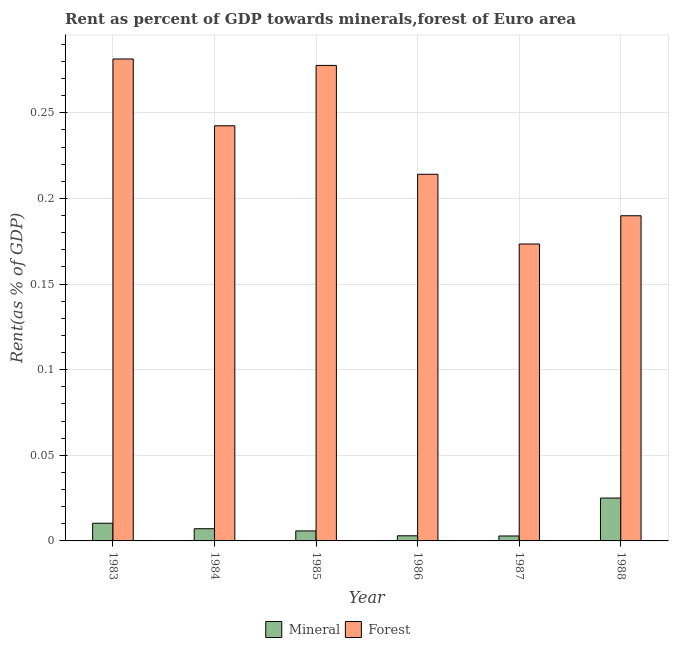How many different coloured bars are there?
Give a very brief answer. 2. How many groups of bars are there?
Your response must be concise. 6. What is the label of the 2nd group of bars from the left?
Keep it short and to the point. 1984. What is the forest rent in 1985?
Offer a very short reply. 0.28. Across all years, what is the maximum forest rent?
Your answer should be compact. 0.28. Across all years, what is the minimum forest rent?
Make the answer very short. 0.17. In which year was the mineral rent maximum?
Offer a terse response. 1988. What is the total mineral rent in the graph?
Offer a very short reply. 0.05. What is the difference between the mineral rent in 1984 and that in 1988?
Make the answer very short. -0.02. What is the difference between the forest rent in 1985 and the mineral rent in 1987?
Give a very brief answer. 0.1. What is the average forest rent per year?
Make the answer very short. 0.23. In the year 1988, what is the difference between the forest rent and mineral rent?
Provide a short and direct response. 0. In how many years, is the mineral rent greater than 0.01 %?
Keep it short and to the point. 2. What is the ratio of the forest rent in 1984 to that in 1987?
Your response must be concise. 1.4. What is the difference between the highest and the second highest mineral rent?
Provide a short and direct response. 0.01. What is the difference between the highest and the lowest forest rent?
Offer a terse response. 0.11. Is the sum of the forest rent in 1986 and 1988 greater than the maximum mineral rent across all years?
Ensure brevity in your answer.  Yes. What does the 2nd bar from the left in 1983 represents?
Give a very brief answer. Forest. What does the 2nd bar from the right in 1983 represents?
Provide a short and direct response. Mineral. Are all the bars in the graph horizontal?
Keep it short and to the point. No. How many years are there in the graph?
Provide a succinct answer. 6. What is the difference between two consecutive major ticks on the Y-axis?
Offer a very short reply. 0.05. Are the values on the major ticks of Y-axis written in scientific E-notation?
Make the answer very short. No. Does the graph contain any zero values?
Your answer should be very brief. No. Does the graph contain grids?
Make the answer very short. Yes. How many legend labels are there?
Your answer should be compact. 2. What is the title of the graph?
Provide a succinct answer. Rent as percent of GDP towards minerals,forest of Euro area. Does "Fixed telephone" appear as one of the legend labels in the graph?
Make the answer very short. No. What is the label or title of the X-axis?
Make the answer very short. Year. What is the label or title of the Y-axis?
Keep it short and to the point. Rent(as % of GDP). What is the Rent(as % of GDP) of Mineral in 1983?
Provide a short and direct response. 0.01. What is the Rent(as % of GDP) of Forest in 1983?
Provide a short and direct response. 0.28. What is the Rent(as % of GDP) of Mineral in 1984?
Your response must be concise. 0.01. What is the Rent(as % of GDP) of Forest in 1984?
Your answer should be compact. 0.24. What is the Rent(as % of GDP) in Mineral in 1985?
Provide a short and direct response. 0.01. What is the Rent(as % of GDP) of Forest in 1985?
Offer a very short reply. 0.28. What is the Rent(as % of GDP) of Mineral in 1986?
Your answer should be very brief. 0. What is the Rent(as % of GDP) of Forest in 1986?
Provide a succinct answer. 0.21. What is the Rent(as % of GDP) in Mineral in 1987?
Provide a succinct answer. 0. What is the Rent(as % of GDP) of Forest in 1987?
Keep it short and to the point. 0.17. What is the Rent(as % of GDP) of Mineral in 1988?
Make the answer very short. 0.03. What is the Rent(as % of GDP) in Forest in 1988?
Keep it short and to the point. 0.19. Across all years, what is the maximum Rent(as % of GDP) of Mineral?
Your answer should be very brief. 0.03. Across all years, what is the maximum Rent(as % of GDP) of Forest?
Your response must be concise. 0.28. Across all years, what is the minimum Rent(as % of GDP) in Mineral?
Keep it short and to the point. 0. Across all years, what is the minimum Rent(as % of GDP) in Forest?
Give a very brief answer. 0.17. What is the total Rent(as % of GDP) in Mineral in the graph?
Give a very brief answer. 0.05. What is the total Rent(as % of GDP) of Forest in the graph?
Keep it short and to the point. 1.38. What is the difference between the Rent(as % of GDP) in Mineral in 1983 and that in 1984?
Give a very brief answer. 0. What is the difference between the Rent(as % of GDP) in Forest in 1983 and that in 1984?
Your answer should be very brief. 0.04. What is the difference between the Rent(as % of GDP) in Mineral in 1983 and that in 1985?
Your answer should be very brief. 0. What is the difference between the Rent(as % of GDP) of Forest in 1983 and that in 1985?
Your answer should be compact. 0. What is the difference between the Rent(as % of GDP) of Mineral in 1983 and that in 1986?
Your answer should be compact. 0.01. What is the difference between the Rent(as % of GDP) in Forest in 1983 and that in 1986?
Ensure brevity in your answer.  0.07. What is the difference between the Rent(as % of GDP) of Mineral in 1983 and that in 1987?
Make the answer very short. 0.01. What is the difference between the Rent(as % of GDP) in Forest in 1983 and that in 1987?
Your response must be concise. 0.11. What is the difference between the Rent(as % of GDP) in Mineral in 1983 and that in 1988?
Keep it short and to the point. -0.01. What is the difference between the Rent(as % of GDP) of Forest in 1983 and that in 1988?
Keep it short and to the point. 0.09. What is the difference between the Rent(as % of GDP) of Mineral in 1984 and that in 1985?
Provide a short and direct response. 0. What is the difference between the Rent(as % of GDP) of Forest in 1984 and that in 1985?
Offer a terse response. -0.04. What is the difference between the Rent(as % of GDP) of Mineral in 1984 and that in 1986?
Keep it short and to the point. 0. What is the difference between the Rent(as % of GDP) in Forest in 1984 and that in 1986?
Your response must be concise. 0.03. What is the difference between the Rent(as % of GDP) of Mineral in 1984 and that in 1987?
Your answer should be compact. 0. What is the difference between the Rent(as % of GDP) of Forest in 1984 and that in 1987?
Your answer should be very brief. 0.07. What is the difference between the Rent(as % of GDP) of Mineral in 1984 and that in 1988?
Keep it short and to the point. -0.02. What is the difference between the Rent(as % of GDP) in Forest in 1984 and that in 1988?
Make the answer very short. 0.05. What is the difference between the Rent(as % of GDP) in Mineral in 1985 and that in 1986?
Give a very brief answer. 0. What is the difference between the Rent(as % of GDP) of Forest in 1985 and that in 1986?
Give a very brief answer. 0.06. What is the difference between the Rent(as % of GDP) of Mineral in 1985 and that in 1987?
Your response must be concise. 0. What is the difference between the Rent(as % of GDP) in Forest in 1985 and that in 1987?
Keep it short and to the point. 0.1. What is the difference between the Rent(as % of GDP) of Mineral in 1985 and that in 1988?
Offer a terse response. -0.02. What is the difference between the Rent(as % of GDP) of Forest in 1985 and that in 1988?
Keep it short and to the point. 0.09. What is the difference between the Rent(as % of GDP) in Forest in 1986 and that in 1987?
Your answer should be very brief. 0.04. What is the difference between the Rent(as % of GDP) of Mineral in 1986 and that in 1988?
Your answer should be very brief. -0.02. What is the difference between the Rent(as % of GDP) in Forest in 1986 and that in 1988?
Your answer should be very brief. 0.02. What is the difference between the Rent(as % of GDP) in Mineral in 1987 and that in 1988?
Give a very brief answer. -0.02. What is the difference between the Rent(as % of GDP) of Forest in 1987 and that in 1988?
Provide a succinct answer. -0.02. What is the difference between the Rent(as % of GDP) of Mineral in 1983 and the Rent(as % of GDP) of Forest in 1984?
Make the answer very short. -0.23. What is the difference between the Rent(as % of GDP) in Mineral in 1983 and the Rent(as % of GDP) in Forest in 1985?
Offer a very short reply. -0.27. What is the difference between the Rent(as % of GDP) of Mineral in 1983 and the Rent(as % of GDP) of Forest in 1986?
Offer a very short reply. -0.2. What is the difference between the Rent(as % of GDP) in Mineral in 1983 and the Rent(as % of GDP) in Forest in 1987?
Your answer should be compact. -0.16. What is the difference between the Rent(as % of GDP) in Mineral in 1983 and the Rent(as % of GDP) in Forest in 1988?
Make the answer very short. -0.18. What is the difference between the Rent(as % of GDP) of Mineral in 1984 and the Rent(as % of GDP) of Forest in 1985?
Offer a terse response. -0.27. What is the difference between the Rent(as % of GDP) in Mineral in 1984 and the Rent(as % of GDP) in Forest in 1986?
Provide a succinct answer. -0.21. What is the difference between the Rent(as % of GDP) of Mineral in 1984 and the Rent(as % of GDP) of Forest in 1987?
Your answer should be very brief. -0.17. What is the difference between the Rent(as % of GDP) of Mineral in 1984 and the Rent(as % of GDP) of Forest in 1988?
Make the answer very short. -0.18. What is the difference between the Rent(as % of GDP) of Mineral in 1985 and the Rent(as % of GDP) of Forest in 1986?
Offer a terse response. -0.21. What is the difference between the Rent(as % of GDP) in Mineral in 1985 and the Rent(as % of GDP) in Forest in 1987?
Provide a short and direct response. -0.17. What is the difference between the Rent(as % of GDP) of Mineral in 1985 and the Rent(as % of GDP) of Forest in 1988?
Keep it short and to the point. -0.18. What is the difference between the Rent(as % of GDP) in Mineral in 1986 and the Rent(as % of GDP) in Forest in 1987?
Keep it short and to the point. -0.17. What is the difference between the Rent(as % of GDP) of Mineral in 1986 and the Rent(as % of GDP) of Forest in 1988?
Provide a succinct answer. -0.19. What is the difference between the Rent(as % of GDP) of Mineral in 1987 and the Rent(as % of GDP) of Forest in 1988?
Your response must be concise. -0.19. What is the average Rent(as % of GDP) of Mineral per year?
Ensure brevity in your answer.  0.01. What is the average Rent(as % of GDP) in Forest per year?
Provide a short and direct response. 0.23. In the year 1983, what is the difference between the Rent(as % of GDP) of Mineral and Rent(as % of GDP) of Forest?
Your answer should be very brief. -0.27. In the year 1984, what is the difference between the Rent(as % of GDP) in Mineral and Rent(as % of GDP) in Forest?
Your answer should be compact. -0.24. In the year 1985, what is the difference between the Rent(as % of GDP) of Mineral and Rent(as % of GDP) of Forest?
Make the answer very short. -0.27. In the year 1986, what is the difference between the Rent(as % of GDP) of Mineral and Rent(as % of GDP) of Forest?
Your answer should be very brief. -0.21. In the year 1987, what is the difference between the Rent(as % of GDP) of Mineral and Rent(as % of GDP) of Forest?
Your response must be concise. -0.17. In the year 1988, what is the difference between the Rent(as % of GDP) in Mineral and Rent(as % of GDP) in Forest?
Keep it short and to the point. -0.16. What is the ratio of the Rent(as % of GDP) in Mineral in 1983 to that in 1984?
Keep it short and to the point. 1.45. What is the ratio of the Rent(as % of GDP) in Forest in 1983 to that in 1984?
Your response must be concise. 1.16. What is the ratio of the Rent(as % of GDP) in Mineral in 1983 to that in 1985?
Offer a terse response. 1.77. What is the ratio of the Rent(as % of GDP) in Forest in 1983 to that in 1985?
Your response must be concise. 1.01. What is the ratio of the Rent(as % of GDP) in Mineral in 1983 to that in 1986?
Offer a very short reply. 3.44. What is the ratio of the Rent(as % of GDP) in Forest in 1983 to that in 1986?
Your answer should be very brief. 1.31. What is the ratio of the Rent(as % of GDP) of Mineral in 1983 to that in 1987?
Ensure brevity in your answer.  3.58. What is the ratio of the Rent(as % of GDP) of Forest in 1983 to that in 1987?
Offer a very short reply. 1.62. What is the ratio of the Rent(as % of GDP) in Mineral in 1983 to that in 1988?
Provide a succinct answer. 0.41. What is the ratio of the Rent(as % of GDP) of Forest in 1983 to that in 1988?
Provide a succinct answer. 1.48. What is the ratio of the Rent(as % of GDP) of Mineral in 1984 to that in 1985?
Provide a short and direct response. 1.22. What is the ratio of the Rent(as % of GDP) of Forest in 1984 to that in 1985?
Offer a very short reply. 0.87. What is the ratio of the Rent(as % of GDP) in Mineral in 1984 to that in 1986?
Ensure brevity in your answer.  2.37. What is the ratio of the Rent(as % of GDP) in Forest in 1984 to that in 1986?
Your answer should be compact. 1.13. What is the ratio of the Rent(as % of GDP) of Mineral in 1984 to that in 1987?
Give a very brief answer. 2.47. What is the ratio of the Rent(as % of GDP) in Forest in 1984 to that in 1987?
Give a very brief answer. 1.4. What is the ratio of the Rent(as % of GDP) of Mineral in 1984 to that in 1988?
Offer a very short reply. 0.28. What is the ratio of the Rent(as % of GDP) in Forest in 1984 to that in 1988?
Provide a succinct answer. 1.28. What is the ratio of the Rent(as % of GDP) in Mineral in 1985 to that in 1986?
Provide a succinct answer. 1.95. What is the ratio of the Rent(as % of GDP) of Forest in 1985 to that in 1986?
Your response must be concise. 1.3. What is the ratio of the Rent(as % of GDP) in Mineral in 1985 to that in 1987?
Provide a short and direct response. 2.03. What is the ratio of the Rent(as % of GDP) in Forest in 1985 to that in 1987?
Your answer should be very brief. 1.6. What is the ratio of the Rent(as % of GDP) of Mineral in 1985 to that in 1988?
Ensure brevity in your answer.  0.23. What is the ratio of the Rent(as % of GDP) in Forest in 1985 to that in 1988?
Your response must be concise. 1.46. What is the ratio of the Rent(as % of GDP) of Mineral in 1986 to that in 1987?
Your answer should be very brief. 1.04. What is the ratio of the Rent(as % of GDP) of Forest in 1986 to that in 1987?
Give a very brief answer. 1.23. What is the ratio of the Rent(as % of GDP) of Mineral in 1986 to that in 1988?
Your response must be concise. 0.12. What is the ratio of the Rent(as % of GDP) in Forest in 1986 to that in 1988?
Offer a terse response. 1.13. What is the ratio of the Rent(as % of GDP) in Mineral in 1987 to that in 1988?
Ensure brevity in your answer.  0.12. What is the ratio of the Rent(as % of GDP) of Forest in 1987 to that in 1988?
Your answer should be very brief. 0.91. What is the difference between the highest and the second highest Rent(as % of GDP) of Mineral?
Make the answer very short. 0.01. What is the difference between the highest and the second highest Rent(as % of GDP) in Forest?
Offer a terse response. 0. What is the difference between the highest and the lowest Rent(as % of GDP) of Mineral?
Make the answer very short. 0.02. What is the difference between the highest and the lowest Rent(as % of GDP) of Forest?
Your answer should be compact. 0.11. 